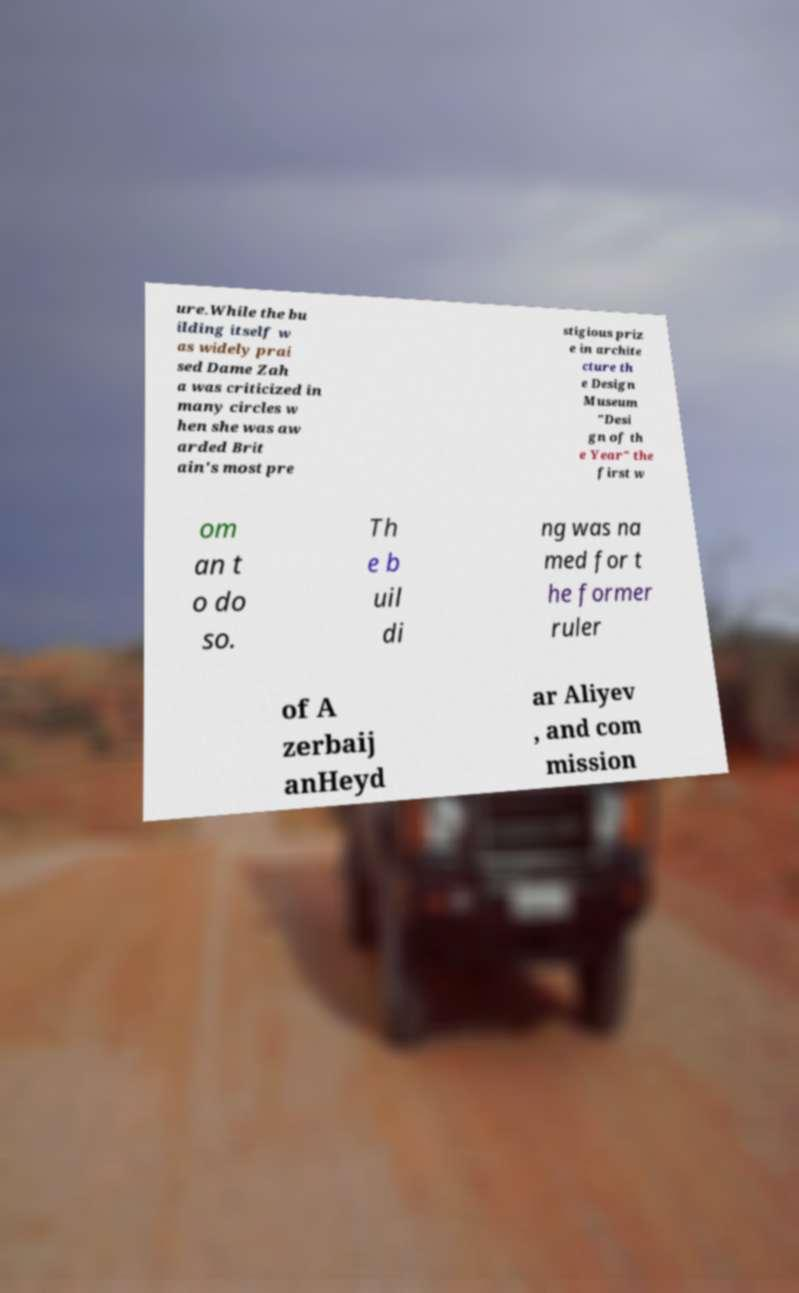There's text embedded in this image that I need extracted. Can you transcribe it verbatim? ure.While the bu ilding itself w as widely prai sed Dame Zah a was criticized in many circles w hen she was aw arded Brit ain's most pre stigious priz e in archite cture th e Design Museum "Desi gn of th e Year" the first w om an t o do so. Th e b uil di ng was na med for t he former ruler of A zerbaij anHeyd ar Aliyev , and com mission 